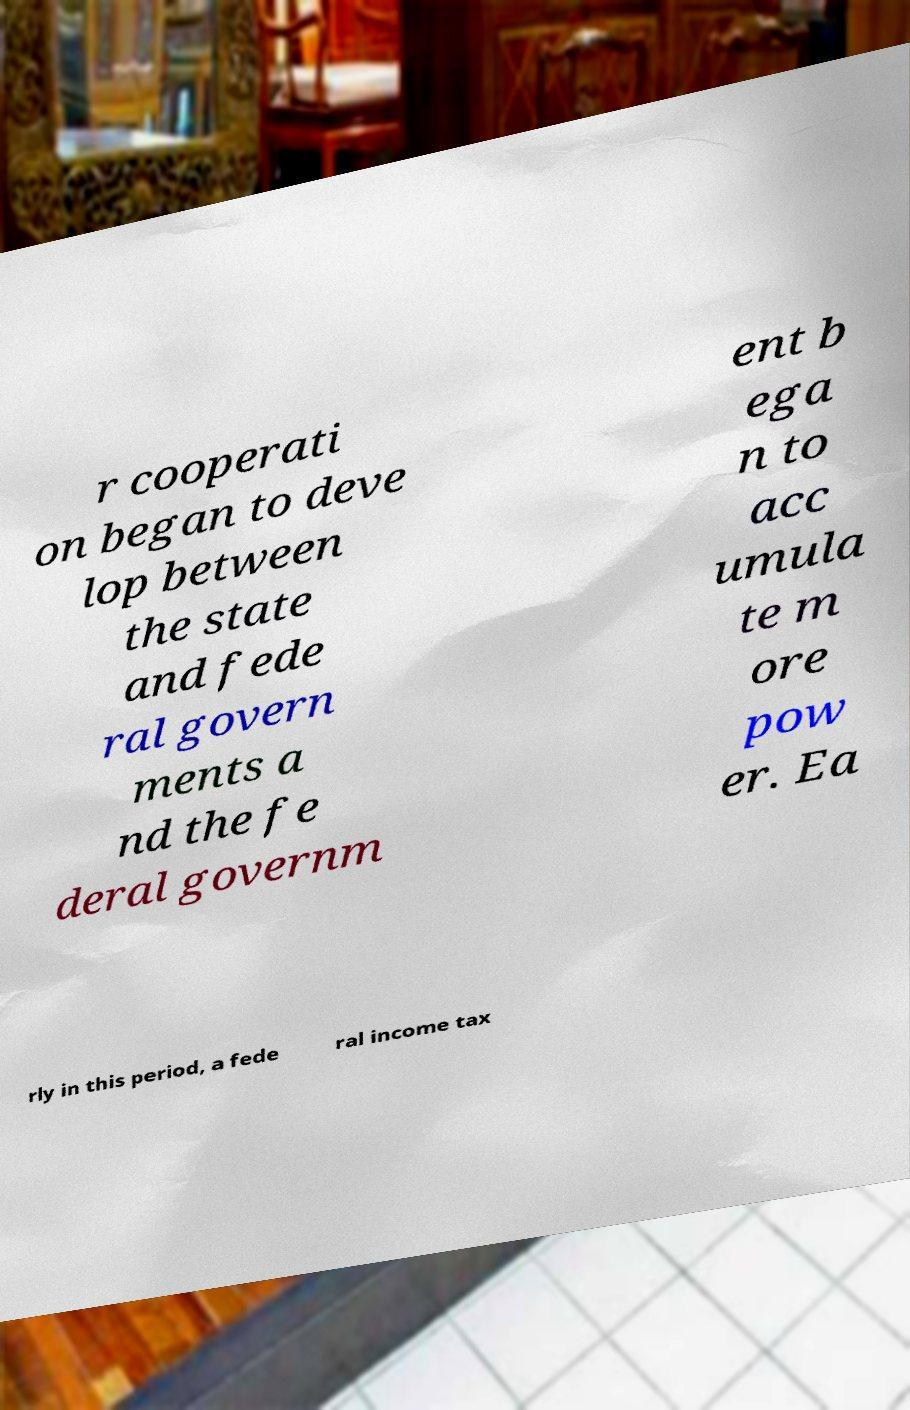Can you accurately transcribe the text from the provided image for me? r cooperati on began to deve lop between the state and fede ral govern ments a nd the fe deral governm ent b ega n to acc umula te m ore pow er. Ea rly in this period, a fede ral income tax 